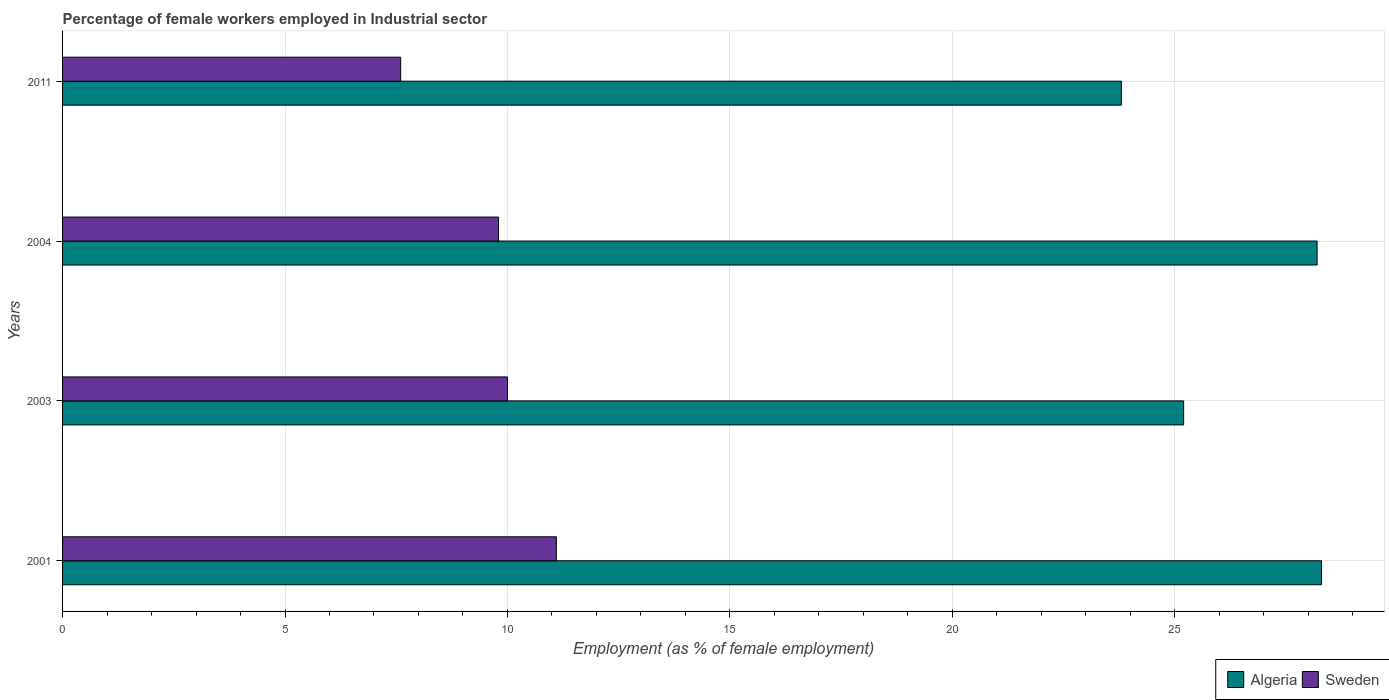How many bars are there on the 3rd tick from the top?
Make the answer very short. 2. How many bars are there on the 1st tick from the bottom?
Your response must be concise. 2. What is the label of the 1st group of bars from the top?
Keep it short and to the point. 2011. What is the percentage of females employed in Industrial sector in Sweden in 2004?
Provide a short and direct response. 9.8. Across all years, what is the maximum percentage of females employed in Industrial sector in Sweden?
Give a very brief answer. 11.1. Across all years, what is the minimum percentage of females employed in Industrial sector in Sweden?
Ensure brevity in your answer.  7.6. What is the total percentage of females employed in Industrial sector in Algeria in the graph?
Offer a terse response. 105.5. What is the difference between the percentage of females employed in Industrial sector in Sweden in 2001 and that in 2003?
Provide a short and direct response. 1.1. What is the difference between the percentage of females employed in Industrial sector in Sweden in 2004 and the percentage of females employed in Industrial sector in Algeria in 2003?
Keep it short and to the point. -15.4. What is the average percentage of females employed in Industrial sector in Algeria per year?
Make the answer very short. 26.38. In the year 2004, what is the difference between the percentage of females employed in Industrial sector in Sweden and percentage of females employed in Industrial sector in Algeria?
Offer a very short reply. -18.4. In how many years, is the percentage of females employed in Industrial sector in Sweden greater than 22 %?
Provide a succinct answer. 0. What is the ratio of the percentage of females employed in Industrial sector in Algeria in 2003 to that in 2011?
Ensure brevity in your answer.  1.06. What is the difference between the highest and the second highest percentage of females employed in Industrial sector in Sweden?
Keep it short and to the point. 1.1. Is the sum of the percentage of females employed in Industrial sector in Sweden in 2003 and 2011 greater than the maximum percentage of females employed in Industrial sector in Algeria across all years?
Offer a very short reply. No. What does the 1st bar from the top in 2004 represents?
Give a very brief answer. Sweden. What does the 1st bar from the bottom in 2001 represents?
Provide a short and direct response. Algeria. Are all the bars in the graph horizontal?
Make the answer very short. Yes. How many years are there in the graph?
Your answer should be compact. 4. Are the values on the major ticks of X-axis written in scientific E-notation?
Make the answer very short. No. Does the graph contain any zero values?
Offer a terse response. No. Does the graph contain grids?
Provide a succinct answer. Yes. Where does the legend appear in the graph?
Your answer should be very brief. Bottom right. How many legend labels are there?
Give a very brief answer. 2. How are the legend labels stacked?
Offer a very short reply. Horizontal. What is the title of the graph?
Provide a succinct answer. Percentage of female workers employed in Industrial sector. Does "Faeroe Islands" appear as one of the legend labels in the graph?
Your response must be concise. No. What is the label or title of the X-axis?
Your response must be concise. Employment (as % of female employment). What is the Employment (as % of female employment) of Algeria in 2001?
Offer a terse response. 28.3. What is the Employment (as % of female employment) in Sweden in 2001?
Provide a short and direct response. 11.1. What is the Employment (as % of female employment) of Algeria in 2003?
Keep it short and to the point. 25.2. What is the Employment (as % of female employment) in Sweden in 2003?
Your response must be concise. 10. What is the Employment (as % of female employment) of Algeria in 2004?
Give a very brief answer. 28.2. What is the Employment (as % of female employment) in Sweden in 2004?
Offer a terse response. 9.8. What is the Employment (as % of female employment) of Algeria in 2011?
Give a very brief answer. 23.8. What is the Employment (as % of female employment) of Sweden in 2011?
Provide a short and direct response. 7.6. Across all years, what is the maximum Employment (as % of female employment) of Algeria?
Ensure brevity in your answer.  28.3. Across all years, what is the maximum Employment (as % of female employment) of Sweden?
Ensure brevity in your answer.  11.1. Across all years, what is the minimum Employment (as % of female employment) in Algeria?
Offer a terse response. 23.8. Across all years, what is the minimum Employment (as % of female employment) in Sweden?
Your answer should be very brief. 7.6. What is the total Employment (as % of female employment) of Algeria in the graph?
Your response must be concise. 105.5. What is the total Employment (as % of female employment) in Sweden in the graph?
Give a very brief answer. 38.5. What is the difference between the Employment (as % of female employment) in Algeria in 2001 and that in 2003?
Offer a terse response. 3.1. What is the difference between the Employment (as % of female employment) in Sweden in 2001 and that in 2004?
Give a very brief answer. 1.3. What is the difference between the Employment (as % of female employment) of Sweden in 2001 and that in 2011?
Give a very brief answer. 3.5. What is the difference between the Employment (as % of female employment) of Algeria in 2003 and that in 2011?
Provide a succinct answer. 1.4. What is the difference between the Employment (as % of female employment) of Algeria in 2001 and the Employment (as % of female employment) of Sweden in 2004?
Ensure brevity in your answer.  18.5. What is the difference between the Employment (as % of female employment) in Algeria in 2001 and the Employment (as % of female employment) in Sweden in 2011?
Offer a very short reply. 20.7. What is the difference between the Employment (as % of female employment) of Algeria in 2003 and the Employment (as % of female employment) of Sweden in 2011?
Your answer should be compact. 17.6. What is the difference between the Employment (as % of female employment) of Algeria in 2004 and the Employment (as % of female employment) of Sweden in 2011?
Give a very brief answer. 20.6. What is the average Employment (as % of female employment) in Algeria per year?
Your answer should be very brief. 26.38. What is the average Employment (as % of female employment) of Sweden per year?
Give a very brief answer. 9.62. In the year 2004, what is the difference between the Employment (as % of female employment) of Algeria and Employment (as % of female employment) of Sweden?
Provide a short and direct response. 18.4. In the year 2011, what is the difference between the Employment (as % of female employment) of Algeria and Employment (as % of female employment) of Sweden?
Make the answer very short. 16.2. What is the ratio of the Employment (as % of female employment) of Algeria in 2001 to that in 2003?
Provide a short and direct response. 1.12. What is the ratio of the Employment (as % of female employment) of Sweden in 2001 to that in 2003?
Give a very brief answer. 1.11. What is the ratio of the Employment (as % of female employment) of Algeria in 2001 to that in 2004?
Provide a short and direct response. 1. What is the ratio of the Employment (as % of female employment) in Sweden in 2001 to that in 2004?
Your response must be concise. 1.13. What is the ratio of the Employment (as % of female employment) of Algeria in 2001 to that in 2011?
Your response must be concise. 1.19. What is the ratio of the Employment (as % of female employment) of Sweden in 2001 to that in 2011?
Offer a terse response. 1.46. What is the ratio of the Employment (as % of female employment) of Algeria in 2003 to that in 2004?
Provide a succinct answer. 0.89. What is the ratio of the Employment (as % of female employment) of Sweden in 2003 to that in 2004?
Offer a very short reply. 1.02. What is the ratio of the Employment (as % of female employment) in Algeria in 2003 to that in 2011?
Your answer should be compact. 1.06. What is the ratio of the Employment (as % of female employment) of Sweden in 2003 to that in 2011?
Keep it short and to the point. 1.32. What is the ratio of the Employment (as % of female employment) in Algeria in 2004 to that in 2011?
Ensure brevity in your answer.  1.18. What is the ratio of the Employment (as % of female employment) of Sweden in 2004 to that in 2011?
Make the answer very short. 1.29. What is the difference between the highest and the second highest Employment (as % of female employment) of Algeria?
Ensure brevity in your answer.  0.1. What is the difference between the highest and the lowest Employment (as % of female employment) in Algeria?
Offer a very short reply. 4.5. What is the difference between the highest and the lowest Employment (as % of female employment) of Sweden?
Ensure brevity in your answer.  3.5. 